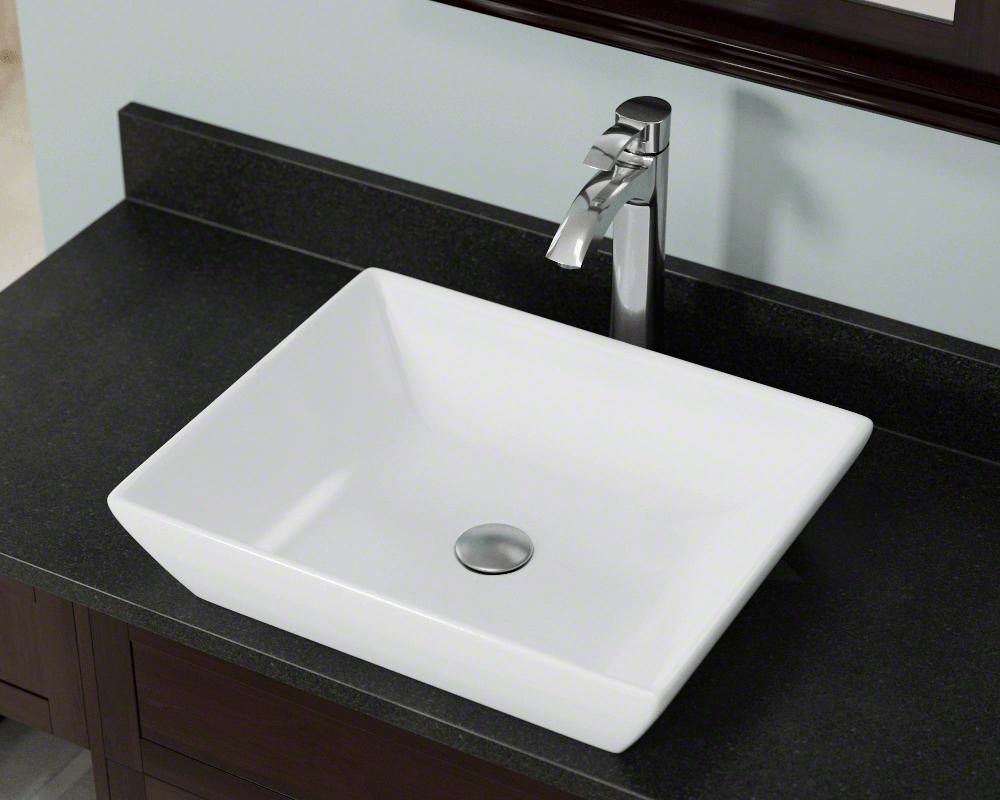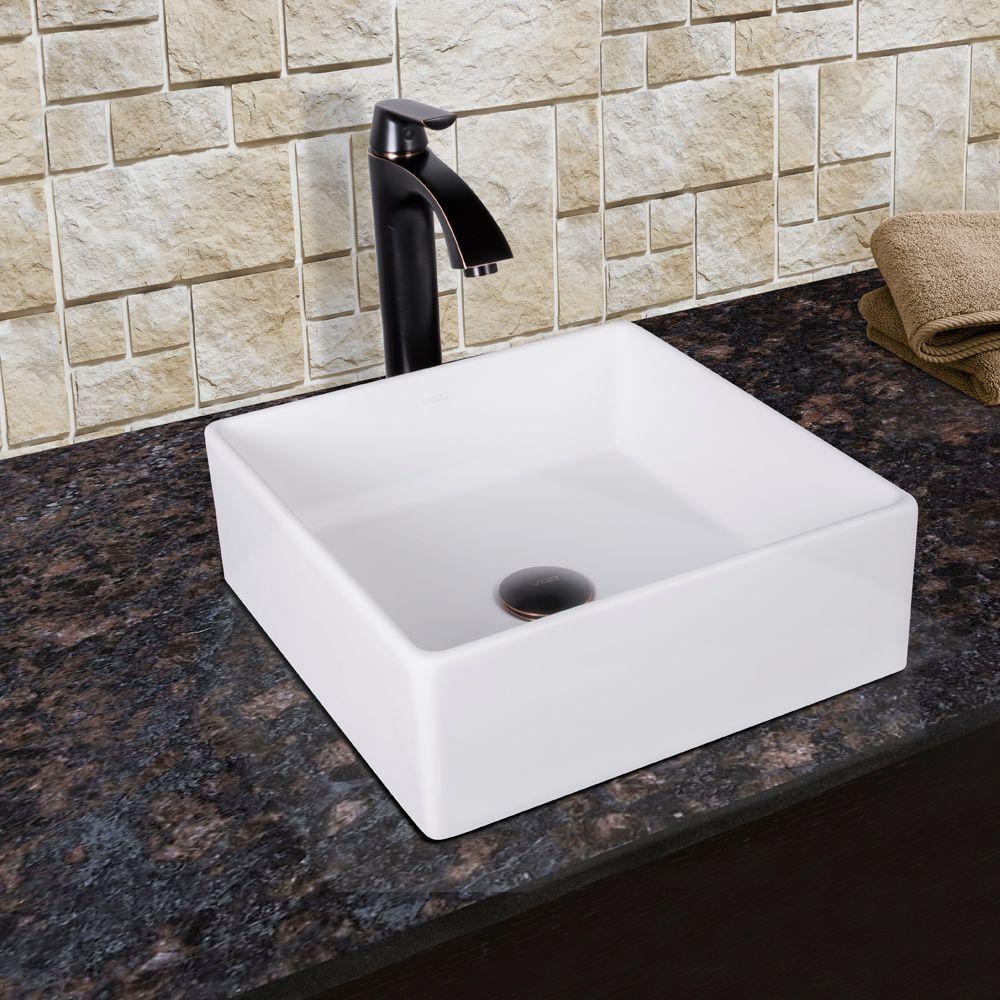The first image is the image on the left, the second image is the image on the right. Analyze the images presented: Is the assertion "Sinks on the left and right share the same shape and faucet style." valid? Answer yes or no. Yes. The first image is the image on the left, the second image is the image on the right. Assess this claim about the two images: "There is an item next to a sink.". Correct or not? Answer yes or no. No. 